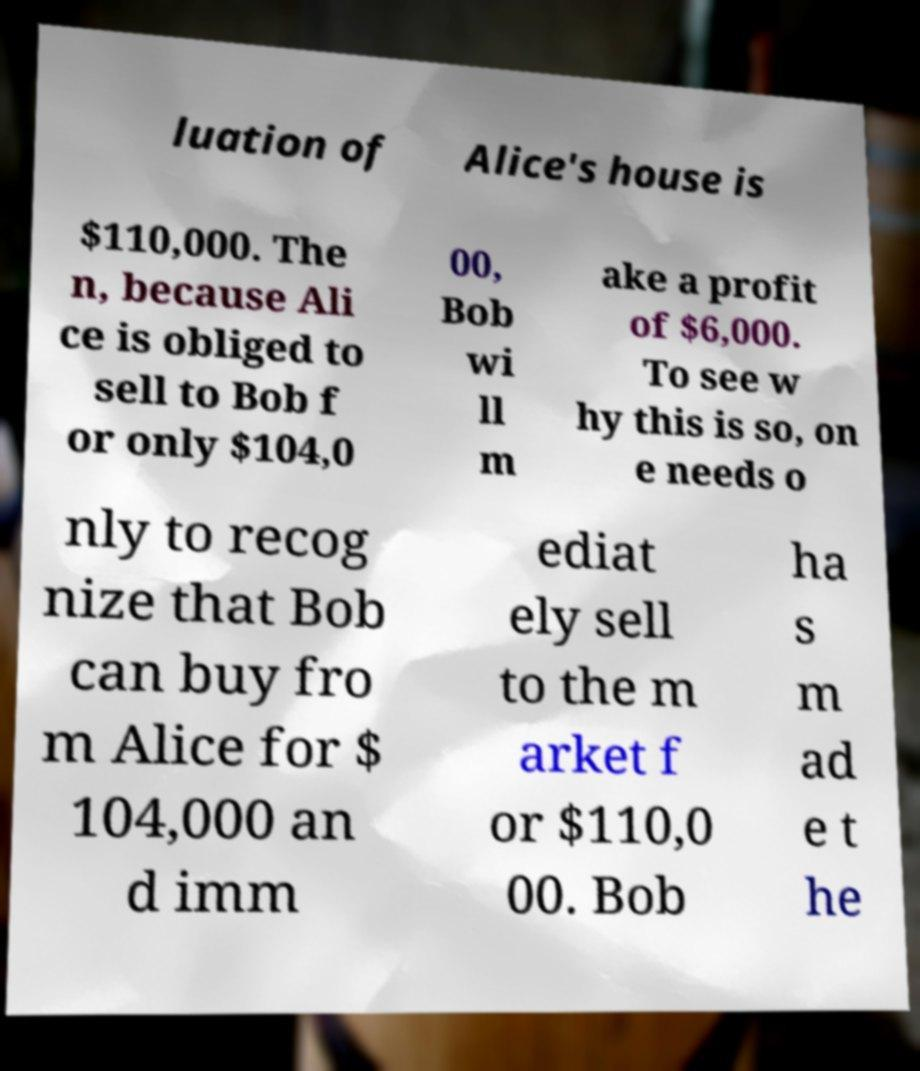Could you extract and type out the text from this image? luation of Alice's house is $110,000. The n, because Ali ce is obliged to sell to Bob f or only $104,0 00, Bob wi ll m ake a profit of $6,000. To see w hy this is so, on e needs o nly to recog nize that Bob can buy fro m Alice for $ 104,000 an d imm ediat ely sell to the m arket f or $110,0 00. Bob ha s m ad e t he 